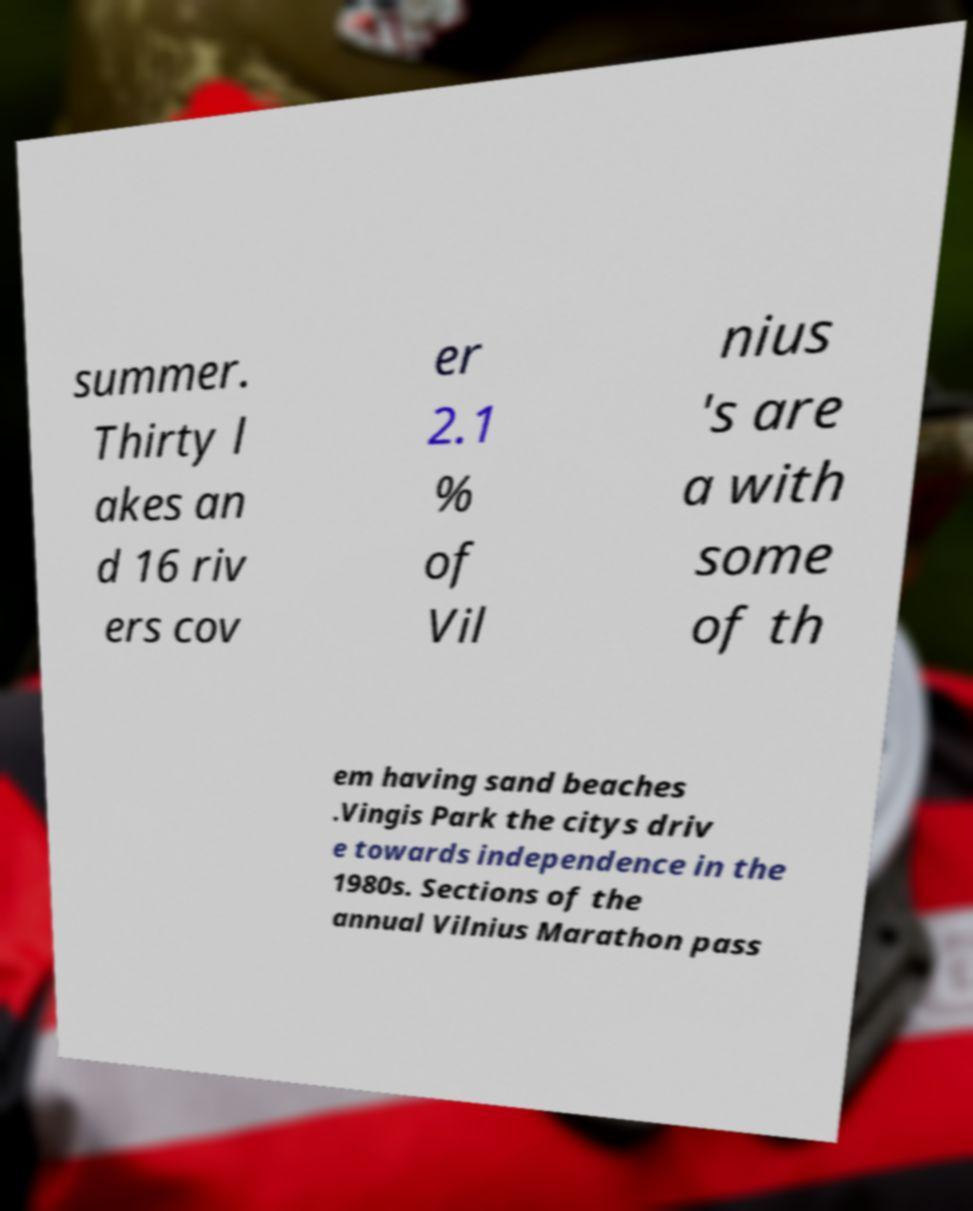What messages or text are displayed in this image? I need them in a readable, typed format. summer. Thirty l akes an d 16 riv ers cov er 2.1 % of Vil nius 's are a with some of th em having sand beaches .Vingis Park the citys driv e towards independence in the 1980s. Sections of the annual Vilnius Marathon pass 